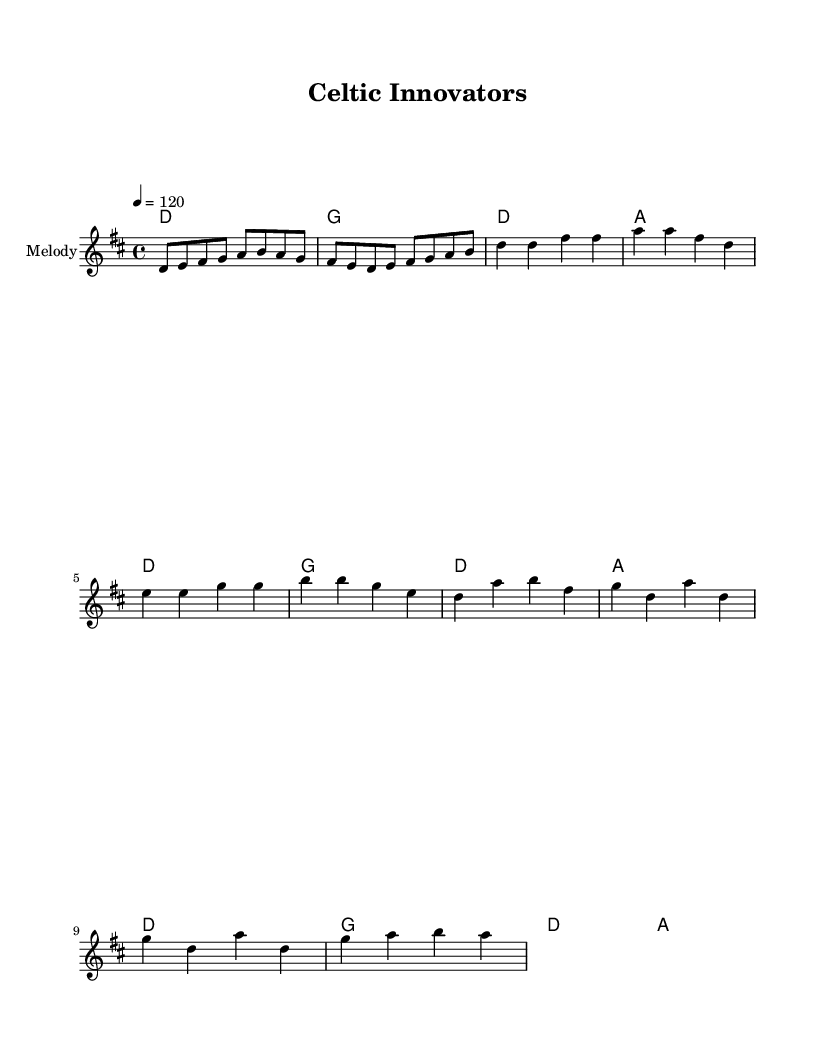What is the key signature of this music? The key signature is indicated by the sharps or flats at the beginning of the staff. In this sheet music, there is a F sharp shown, indicating the presence of one sharp. Therefore, the key is D major.
Answer: D major What is the time signature of this music? The time signature is found at the beginning of the staff, showing how many beats are in each measure. Here, 4/4 indicates four beats per measure.
Answer: 4/4 What is the tempo marking of this piece? The tempo marking is indicated in the header with a specific bpm (beats per minute) value, which shows how fast the music should be played. The marking shows a tempo of 120.
Answer: 120 How many measures are in the melody section? To determine the number of measures, count the vertical lines that separate the groups of notes in the melody section. There are eight measures present in the melody.
Answer: Eight What is the first chord of the piece? The first chord is found in the harmonies section at the beginning, indicated by the first symbol of harmony. This shows a D major chord which is represented by the letter D.
Answer: D How many distinct sections are there in the song structure? The song structure includes distinct sections that can be identified as Intro, Verse, and Chorus. Counting these sections, there are three distinct parts present.
Answer: Three What type of music is this classified as? This piece combines elements of rock music with traditional Irish melodies and harmonies, which fits the description of Celtic rock fusion.
Answer: Celtic rock fusion 